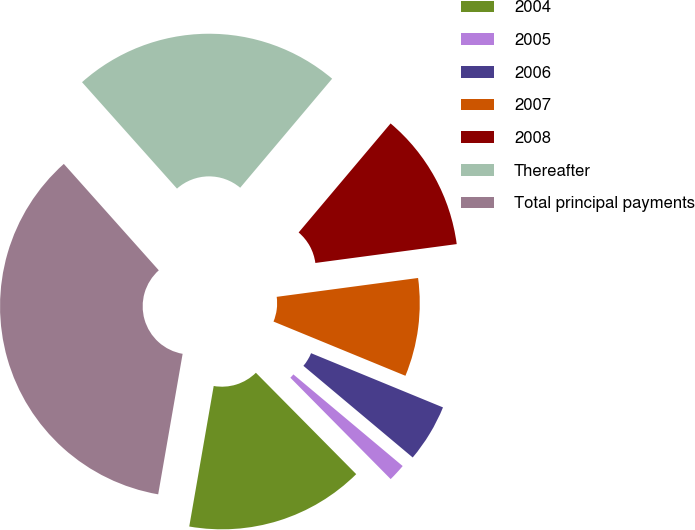Convert chart. <chart><loc_0><loc_0><loc_500><loc_500><pie_chart><fcel>2004<fcel>2005<fcel>2006<fcel>2007<fcel>2008<fcel>Thereafter<fcel>Total principal payments<nl><fcel>15.16%<fcel>1.48%<fcel>4.9%<fcel>8.32%<fcel>11.74%<fcel>22.75%<fcel>35.67%<nl></chart> 